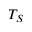Convert formula to latex. <formula><loc_0><loc_0><loc_500><loc_500>T _ { S }</formula> 